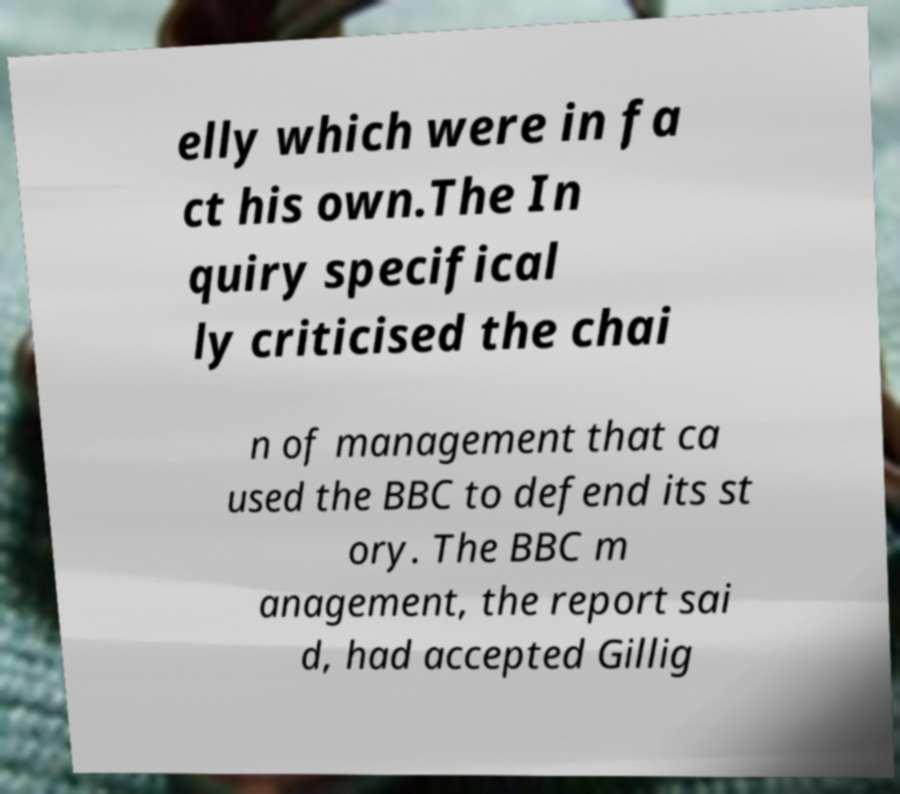Can you accurately transcribe the text from the provided image for me? elly which were in fa ct his own.The In quiry specifical ly criticised the chai n of management that ca used the BBC to defend its st ory. The BBC m anagement, the report sai d, had accepted Gillig 